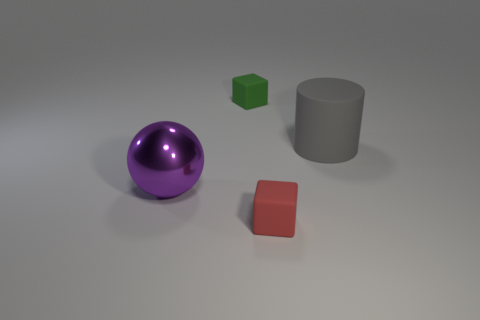The tiny rubber object that is in front of the tiny rubber cube that is behind the matte cube that is in front of the big cylinder is what color?
Offer a terse response. Red. How many tiny things are both behind the shiny object and to the right of the tiny green matte object?
Make the answer very short. 0. What number of cylinders are either tiny matte objects or red matte things?
Offer a very short reply. 0. Are there any small cyan matte cylinders?
Keep it short and to the point. No. How many other objects are the same material as the purple object?
Ensure brevity in your answer.  0. What material is the purple object that is the same size as the gray thing?
Offer a terse response. Metal. There is a small object in front of the large rubber thing; is it the same shape as the large purple object?
Keep it short and to the point. No. What number of things are green cubes on the left side of the gray matte cylinder or large metal cubes?
Provide a short and direct response. 1. There is a gray object that is the same size as the purple thing; what is its shape?
Give a very brief answer. Cylinder. Do the rubber thing that is in front of the purple metal thing and the thing right of the small red matte cube have the same size?
Ensure brevity in your answer.  No. 